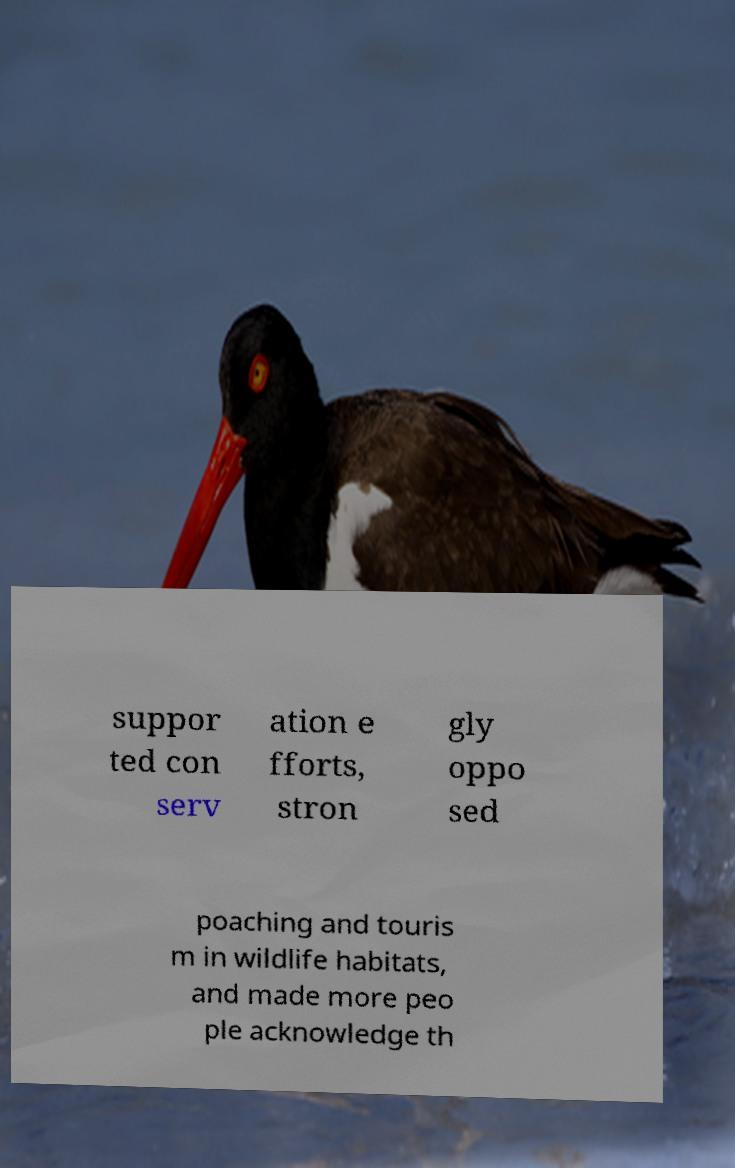I need the written content from this picture converted into text. Can you do that? suppor ted con serv ation e fforts, stron gly oppo sed poaching and touris m in wildlife habitats, and made more peo ple acknowledge th 